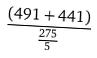<formula> <loc_0><loc_0><loc_500><loc_500>\frac { ( 4 9 1 + 4 4 1 ) } { \frac { 2 7 5 } { 5 } }</formula> 